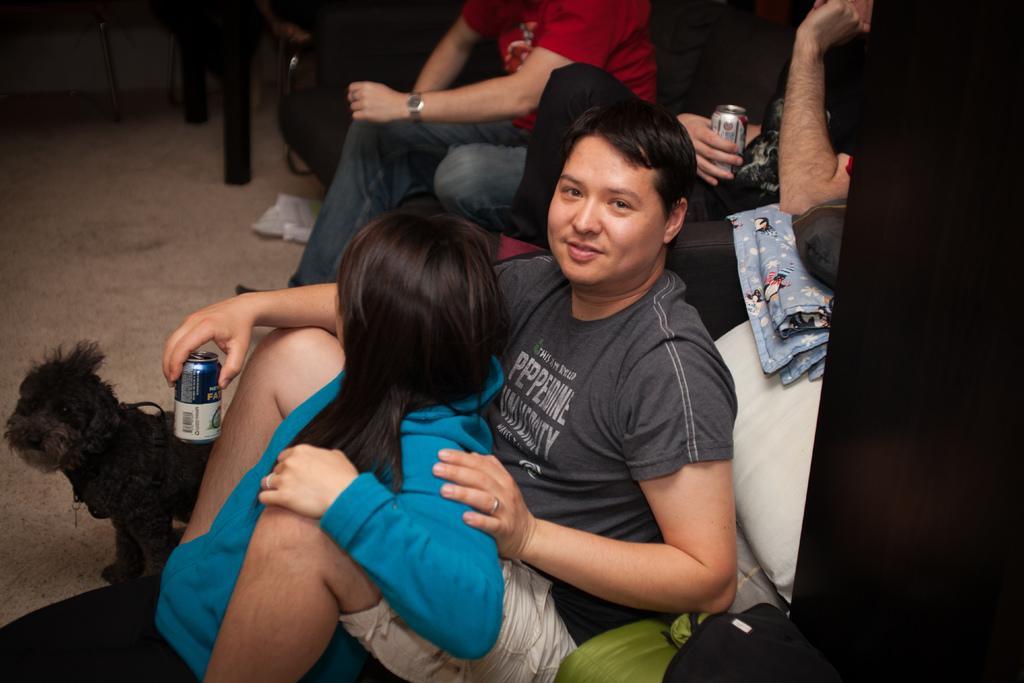Please provide a concise description of this image. Here we can see a man and woman sitting on a platform and the man is holding a tin in his hand and beside them there is a dog on the floor. In the background there are two persons sitting on the sofa and a person is holding a tin in his hand and we can also see cloth,bag and some other objects. 